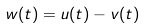<formula> <loc_0><loc_0><loc_500><loc_500>w ( t ) = u ( t ) - v ( t )</formula> 